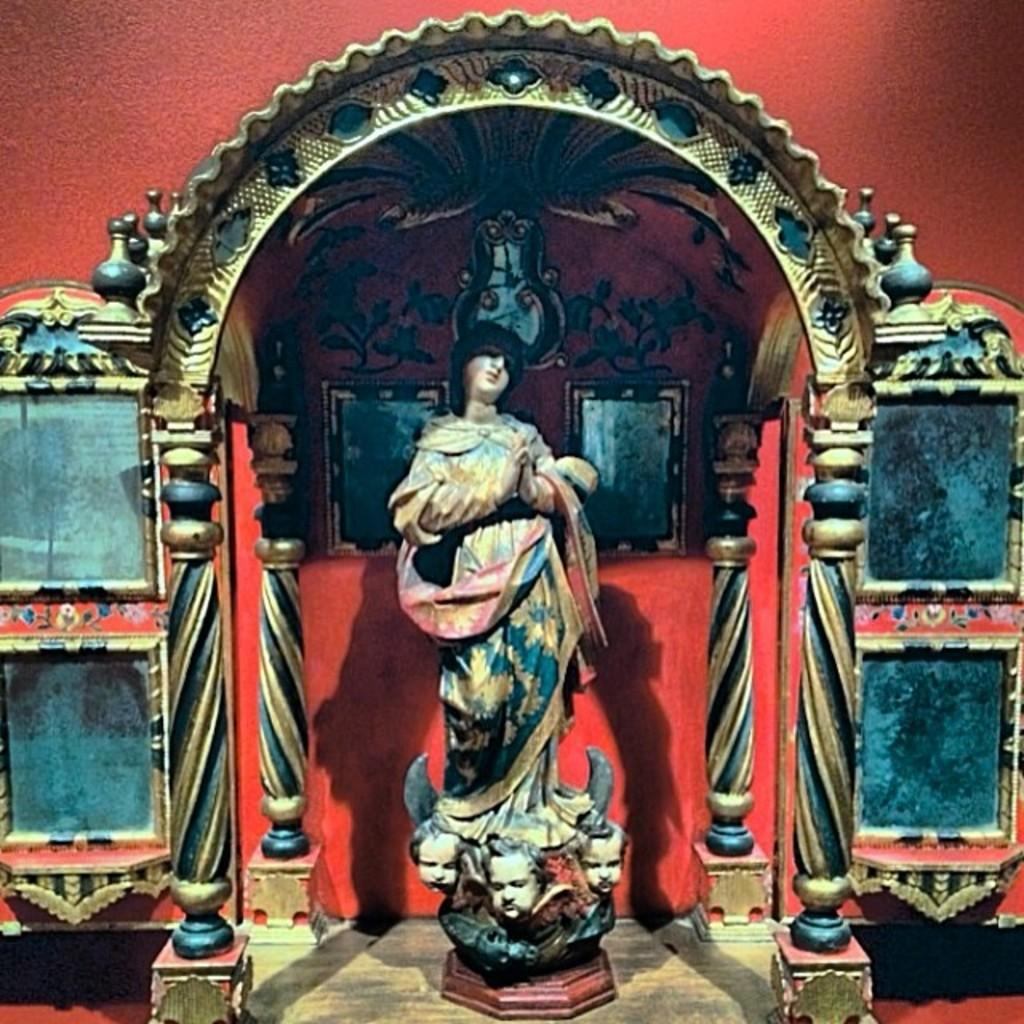What is the main subject in the image? There is a statue in the image. Can you describe the appearance of the statue? The statue is multi-colored. What can be seen in the background of the image? There is an arch in the background of the image. What colors are used for the arch? The arch is in cream and blue colors. What color is the wall in the background? The wall in the background is red. How much debt is the statue in the image responsible for? The statue in the image is not a living entity and therefore cannot be responsible for any debt. Can you see any dinosaurs in the image? There are no dinosaurs present in the image. 